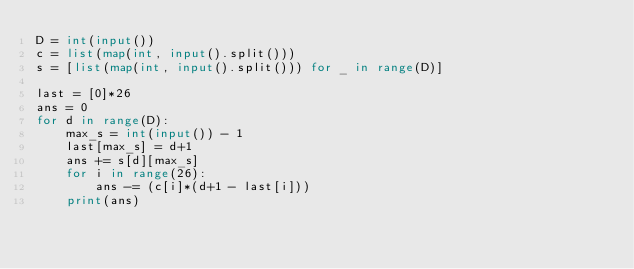<code> <loc_0><loc_0><loc_500><loc_500><_Python_>D = int(input())
c = list(map(int, input().split()))
s = [list(map(int, input().split())) for _ in range(D)]

last = [0]*26
ans = 0
for d in range(D):
    max_s = int(input()) - 1
    last[max_s] = d+1
    ans += s[d][max_s]
    for i in range(26):
        ans -= (c[i]*(d+1 - last[i]))
    print(ans)</code> 